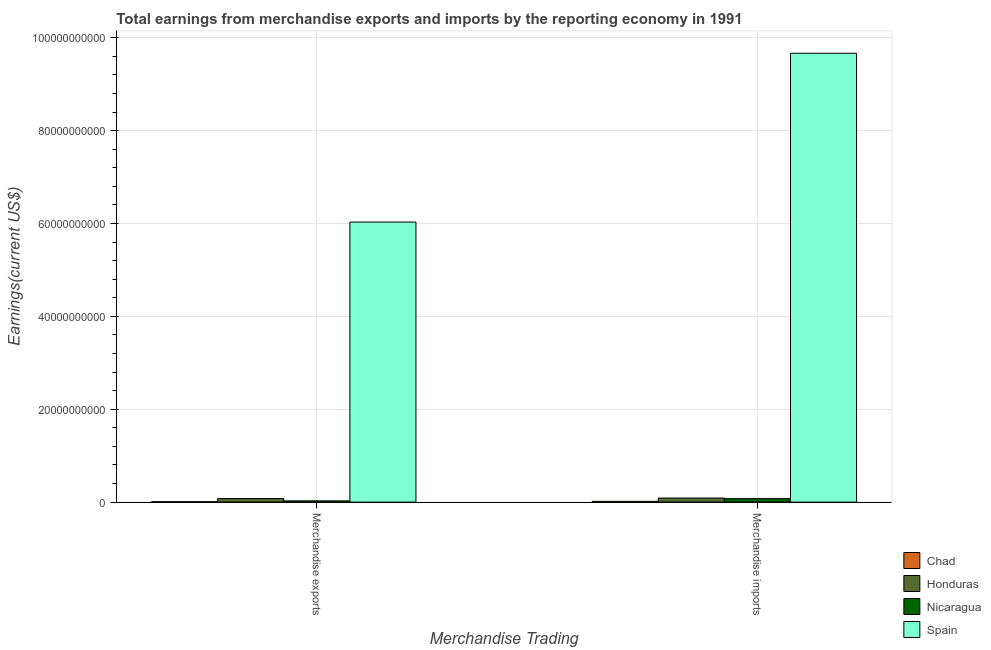How many different coloured bars are there?
Offer a very short reply. 4. How many groups of bars are there?
Offer a terse response. 2. Are the number of bars on each tick of the X-axis equal?
Your answer should be compact. Yes. How many bars are there on the 2nd tick from the left?
Ensure brevity in your answer.  4. What is the label of the 2nd group of bars from the left?
Provide a short and direct response. Merchandise imports. What is the earnings from merchandise imports in Honduras?
Ensure brevity in your answer.  8.80e+08. Across all countries, what is the maximum earnings from merchandise exports?
Give a very brief answer. 6.03e+1. Across all countries, what is the minimum earnings from merchandise imports?
Your response must be concise. 1.68e+08. In which country was the earnings from merchandise exports minimum?
Your response must be concise. Chad. What is the total earnings from merchandise imports in the graph?
Give a very brief answer. 9.85e+1. What is the difference between the earnings from merchandise exports in Honduras and that in Nicaragua?
Ensure brevity in your answer.  5.07e+08. What is the difference between the earnings from merchandise imports in Honduras and the earnings from merchandise exports in Nicaragua?
Offer a terse response. 6.07e+08. What is the average earnings from merchandise imports per country?
Provide a short and direct response. 2.46e+1. What is the difference between the earnings from merchandise imports and earnings from merchandise exports in Nicaragua?
Ensure brevity in your answer.  4.79e+08. In how many countries, is the earnings from merchandise exports greater than 8000000000 US$?
Make the answer very short. 1. What is the ratio of the earnings from merchandise imports in Chad to that in Honduras?
Keep it short and to the point. 0.19. In how many countries, is the earnings from merchandise exports greater than the average earnings from merchandise exports taken over all countries?
Offer a terse response. 1. What does the 4th bar from the right in Merchandise exports represents?
Provide a short and direct response. Chad. How many bars are there?
Your answer should be compact. 8. Does the graph contain grids?
Your answer should be very brief. Yes. How are the legend labels stacked?
Offer a very short reply. Vertical. What is the title of the graph?
Offer a terse response. Total earnings from merchandise exports and imports by the reporting economy in 1991. Does "Myanmar" appear as one of the legend labels in the graph?
Your answer should be compact. No. What is the label or title of the X-axis?
Give a very brief answer. Merchandise Trading. What is the label or title of the Y-axis?
Offer a very short reply. Earnings(current US$). What is the Earnings(current US$) in Chad in Merchandise exports?
Offer a terse response. 9.41e+07. What is the Earnings(current US$) in Honduras in Merchandise exports?
Give a very brief answer. 7.80e+08. What is the Earnings(current US$) of Nicaragua in Merchandise exports?
Keep it short and to the point. 2.72e+08. What is the Earnings(current US$) of Spain in Merchandise exports?
Keep it short and to the point. 6.03e+1. What is the Earnings(current US$) of Chad in Merchandise imports?
Keep it short and to the point. 1.68e+08. What is the Earnings(current US$) of Honduras in Merchandise imports?
Your answer should be compact. 8.80e+08. What is the Earnings(current US$) of Nicaragua in Merchandise imports?
Keep it short and to the point. 7.51e+08. What is the Earnings(current US$) in Spain in Merchandise imports?
Ensure brevity in your answer.  9.67e+1. Across all Merchandise Trading, what is the maximum Earnings(current US$) in Chad?
Give a very brief answer. 1.68e+08. Across all Merchandise Trading, what is the maximum Earnings(current US$) of Honduras?
Make the answer very short. 8.80e+08. Across all Merchandise Trading, what is the maximum Earnings(current US$) of Nicaragua?
Provide a succinct answer. 7.51e+08. Across all Merchandise Trading, what is the maximum Earnings(current US$) of Spain?
Your response must be concise. 9.67e+1. Across all Merchandise Trading, what is the minimum Earnings(current US$) in Chad?
Ensure brevity in your answer.  9.41e+07. Across all Merchandise Trading, what is the minimum Earnings(current US$) of Honduras?
Offer a terse response. 7.80e+08. Across all Merchandise Trading, what is the minimum Earnings(current US$) of Nicaragua?
Offer a terse response. 2.72e+08. Across all Merchandise Trading, what is the minimum Earnings(current US$) of Spain?
Give a very brief answer. 6.03e+1. What is the total Earnings(current US$) of Chad in the graph?
Offer a terse response. 2.62e+08. What is the total Earnings(current US$) of Honduras in the graph?
Your answer should be compact. 1.66e+09. What is the total Earnings(current US$) in Nicaragua in the graph?
Ensure brevity in your answer.  1.02e+09. What is the total Earnings(current US$) of Spain in the graph?
Offer a very short reply. 1.57e+11. What is the difference between the Earnings(current US$) of Chad in Merchandise exports and that in Merchandise imports?
Make the answer very short. -7.39e+07. What is the difference between the Earnings(current US$) in Honduras in Merchandise exports and that in Merchandise imports?
Offer a very short reply. -9.99e+07. What is the difference between the Earnings(current US$) of Nicaragua in Merchandise exports and that in Merchandise imports?
Your response must be concise. -4.79e+08. What is the difference between the Earnings(current US$) of Spain in Merchandise exports and that in Merchandise imports?
Provide a short and direct response. -3.64e+1. What is the difference between the Earnings(current US$) in Chad in Merchandise exports and the Earnings(current US$) in Honduras in Merchandise imports?
Provide a short and direct response. -7.86e+08. What is the difference between the Earnings(current US$) of Chad in Merchandise exports and the Earnings(current US$) of Nicaragua in Merchandise imports?
Provide a short and direct response. -6.57e+08. What is the difference between the Earnings(current US$) in Chad in Merchandise exports and the Earnings(current US$) in Spain in Merchandise imports?
Your answer should be compact. -9.66e+1. What is the difference between the Earnings(current US$) of Honduras in Merchandise exports and the Earnings(current US$) of Nicaragua in Merchandise imports?
Provide a succinct answer. 2.86e+07. What is the difference between the Earnings(current US$) in Honduras in Merchandise exports and the Earnings(current US$) in Spain in Merchandise imports?
Provide a short and direct response. -9.59e+1. What is the difference between the Earnings(current US$) in Nicaragua in Merchandise exports and the Earnings(current US$) in Spain in Merchandise imports?
Your response must be concise. -9.64e+1. What is the average Earnings(current US$) in Chad per Merchandise Trading?
Your answer should be very brief. 1.31e+08. What is the average Earnings(current US$) in Honduras per Merchandise Trading?
Offer a very short reply. 8.30e+08. What is the average Earnings(current US$) in Nicaragua per Merchandise Trading?
Provide a short and direct response. 5.12e+08. What is the average Earnings(current US$) of Spain per Merchandise Trading?
Give a very brief answer. 7.85e+1. What is the difference between the Earnings(current US$) of Chad and Earnings(current US$) of Honduras in Merchandise exports?
Make the answer very short. -6.86e+08. What is the difference between the Earnings(current US$) of Chad and Earnings(current US$) of Nicaragua in Merchandise exports?
Your response must be concise. -1.78e+08. What is the difference between the Earnings(current US$) of Chad and Earnings(current US$) of Spain in Merchandise exports?
Offer a terse response. -6.02e+1. What is the difference between the Earnings(current US$) of Honduras and Earnings(current US$) of Nicaragua in Merchandise exports?
Provide a short and direct response. 5.07e+08. What is the difference between the Earnings(current US$) of Honduras and Earnings(current US$) of Spain in Merchandise exports?
Give a very brief answer. -5.95e+1. What is the difference between the Earnings(current US$) of Nicaragua and Earnings(current US$) of Spain in Merchandise exports?
Provide a succinct answer. -6.00e+1. What is the difference between the Earnings(current US$) in Chad and Earnings(current US$) in Honduras in Merchandise imports?
Ensure brevity in your answer.  -7.12e+08. What is the difference between the Earnings(current US$) in Chad and Earnings(current US$) in Nicaragua in Merchandise imports?
Provide a succinct answer. -5.83e+08. What is the difference between the Earnings(current US$) of Chad and Earnings(current US$) of Spain in Merchandise imports?
Ensure brevity in your answer.  -9.65e+1. What is the difference between the Earnings(current US$) in Honduras and Earnings(current US$) in Nicaragua in Merchandise imports?
Give a very brief answer. 1.28e+08. What is the difference between the Earnings(current US$) of Honduras and Earnings(current US$) of Spain in Merchandise imports?
Ensure brevity in your answer.  -9.58e+1. What is the difference between the Earnings(current US$) in Nicaragua and Earnings(current US$) in Spain in Merchandise imports?
Offer a very short reply. -9.59e+1. What is the ratio of the Earnings(current US$) of Chad in Merchandise exports to that in Merchandise imports?
Offer a very short reply. 0.56. What is the ratio of the Earnings(current US$) in Honduras in Merchandise exports to that in Merchandise imports?
Give a very brief answer. 0.89. What is the ratio of the Earnings(current US$) of Nicaragua in Merchandise exports to that in Merchandise imports?
Ensure brevity in your answer.  0.36. What is the ratio of the Earnings(current US$) of Spain in Merchandise exports to that in Merchandise imports?
Ensure brevity in your answer.  0.62. What is the difference between the highest and the second highest Earnings(current US$) of Chad?
Provide a succinct answer. 7.39e+07. What is the difference between the highest and the second highest Earnings(current US$) of Honduras?
Give a very brief answer. 9.99e+07. What is the difference between the highest and the second highest Earnings(current US$) in Nicaragua?
Give a very brief answer. 4.79e+08. What is the difference between the highest and the second highest Earnings(current US$) of Spain?
Your answer should be very brief. 3.64e+1. What is the difference between the highest and the lowest Earnings(current US$) of Chad?
Offer a terse response. 7.39e+07. What is the difference between the highest and the lowest Earnings(current US$) of Honduras?
Give a very brief answer. 9.99e+07. What is the difference between the highest and the lowest Earnings(current US$) of Nicaragua?
Provide a succinct answer. 4.79e+08. What is the difference between the highest and the lowest Earnings(current US$) in Spain?
Provide a short and direct response. 3.64e+1. 